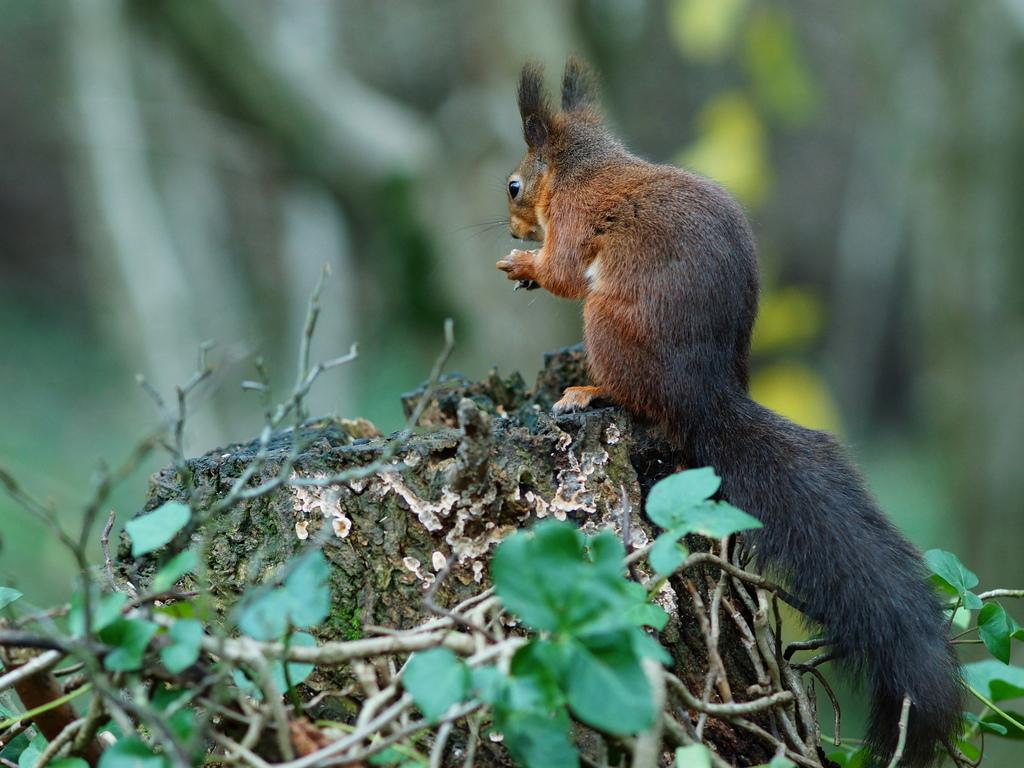What type of animal is in the image? There is a squirrel in the image. Where is the squirrel located? The squirrel is on the bark of a tree. What else can be seen in the image besides the squirrel? There are leaves visible in the image. Can you tell me which actor is playing the role of the squirrel in the image? There is no actor playing the role of the squirrel in the image; it is a real squirrel. Is there an airplane visible in the image? No, there is no airplane present in the image. 